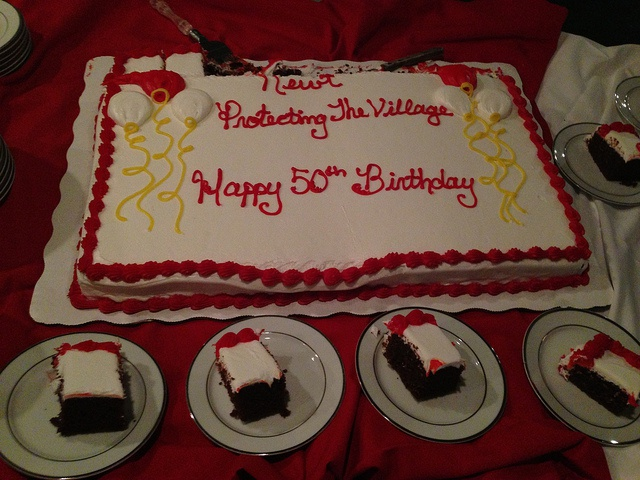Describe the objects in this image and their specific colors. I can see cake in olive, gray, and maroon tones, dining table in olive, maroon, black, and gray tones, cake in olive, black, gray, and maroon tones, cake in olive, black, gray, and maroon tones, and cake in olive, black, gray, and maroon tones in this image. 